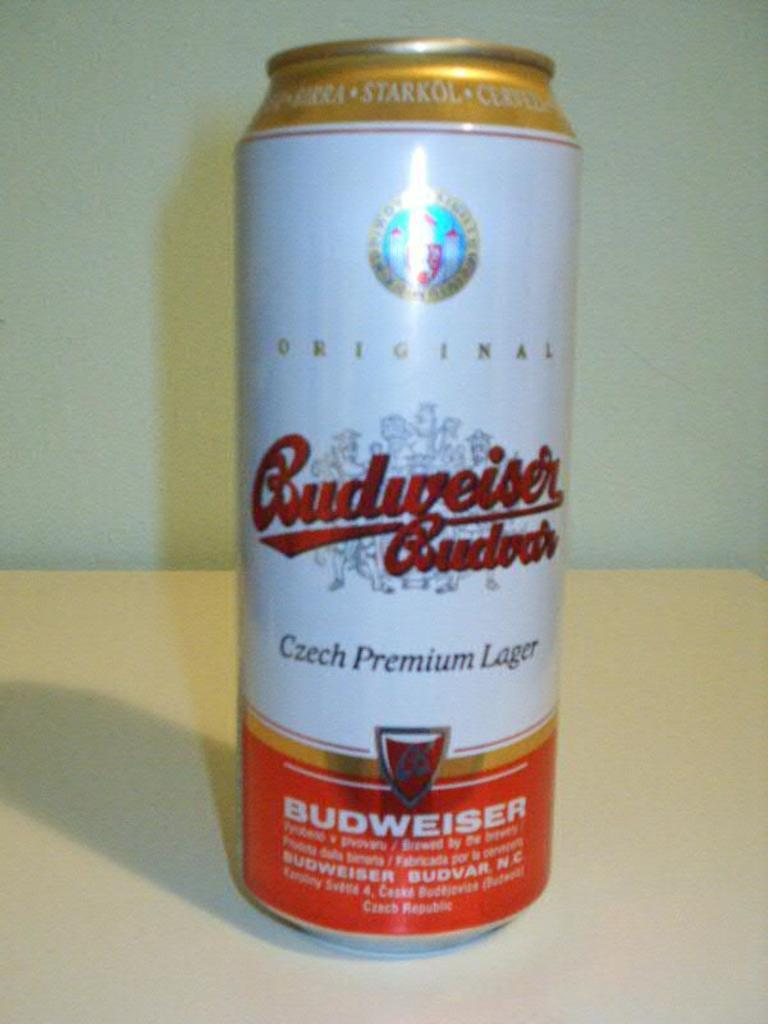<image>
Write a terse but informative summary of the picture. A can of Budweiser, Czech Premium lager has a snowflake behind the name in red. 